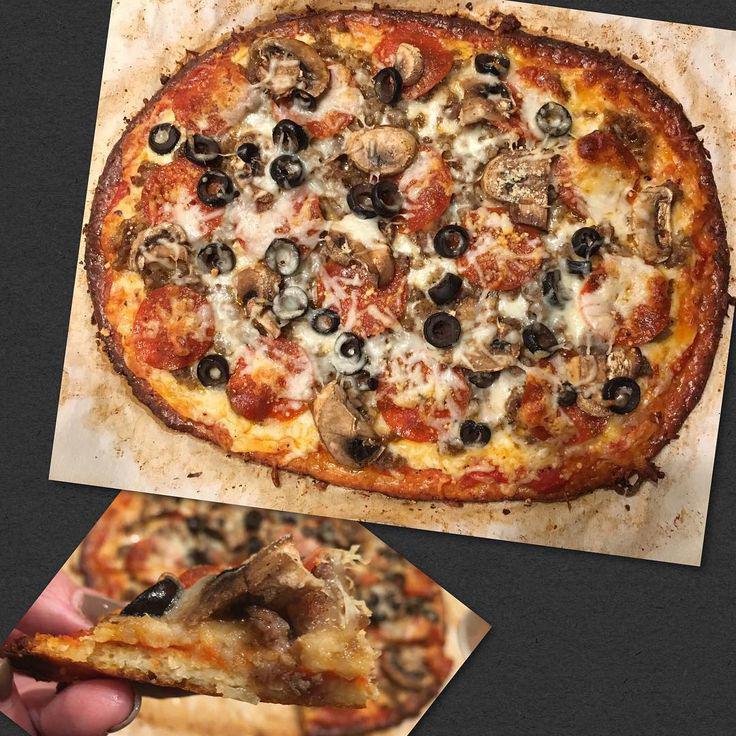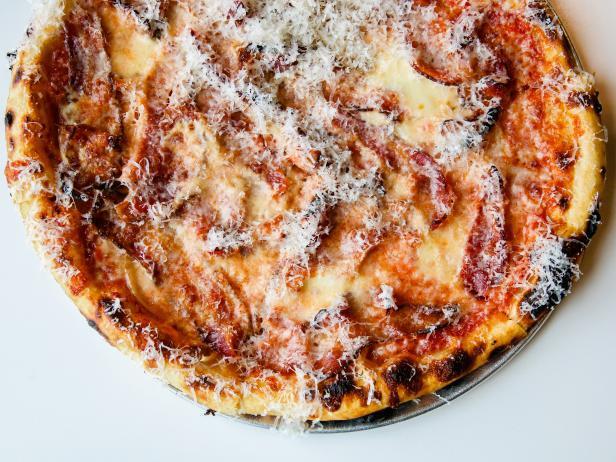The first image is the image on the left, the second image is the image on the right. For the images shown, is this caption "Two pizzas have green toppings covering at least a small portion of the pizza." true? Answer yes or no. No. 